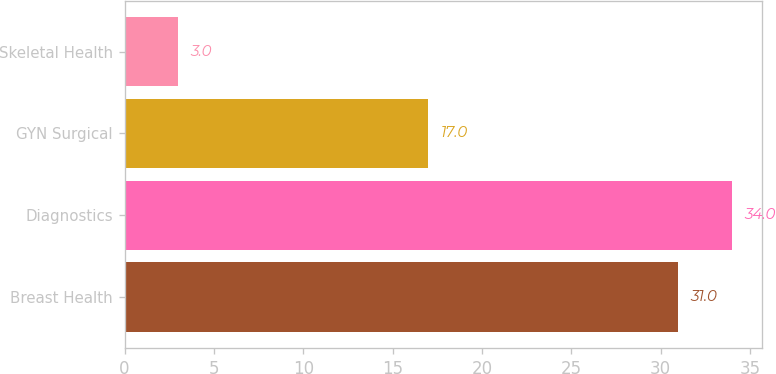Convert chart to OTSL. <chart><loc_0><loc_0><loc_500><loc_500><bar_chart><fcel>Breast Health<fcel>Diagnostics<fcel>GYN Surgical<fcel>Skeletal Health<nl><fcel>31<fcel>34<fcel>17<fcel>3<nl></chart> 